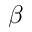<formula> <loc_0><loc_0><loc_500><loc_500>\beta</formula> 